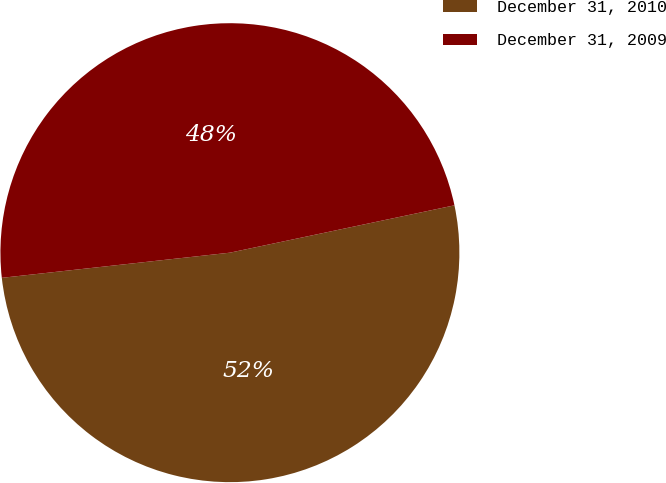<chart> <loc_0><loc_0><loc_500><loc_500><pie_chart><fcel>December 31, 2010<fcel>December 31, 2009<nl><fcel>51.56%<fcel>48.44%<nl></chart> 